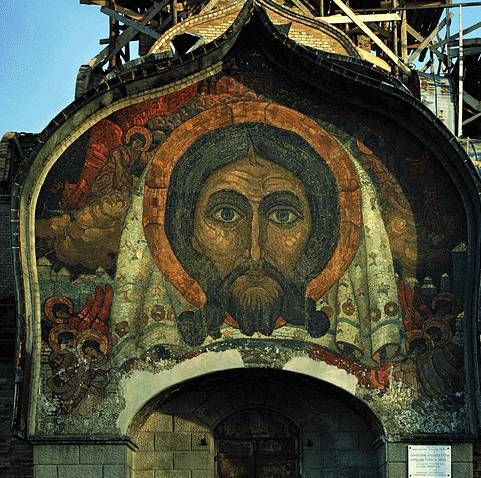Can you describe the main features of this image for me? The image showcases a stunning example of Byzantine mosaic art, prominently featuring a depiction of Jesus Christ. The face of Christ is central, rendered in a palette of deep reds, vibrant golds, and calming greens, typical of the vibrant and symbolic color scheme used in Byzantine artworks. The mosaic is set within a pointed arch, contributing to a dramatic and venerable appearance. Notably, the presence of construction scaffolding indicates ongoing restoration efforts, highlighting the continued reverence and preservation of this historical artifact. This piece is a quintessential example of Byzantine religious art, illustrating not only artistic skill but also a deep spiritual resonance felt through centuries. 